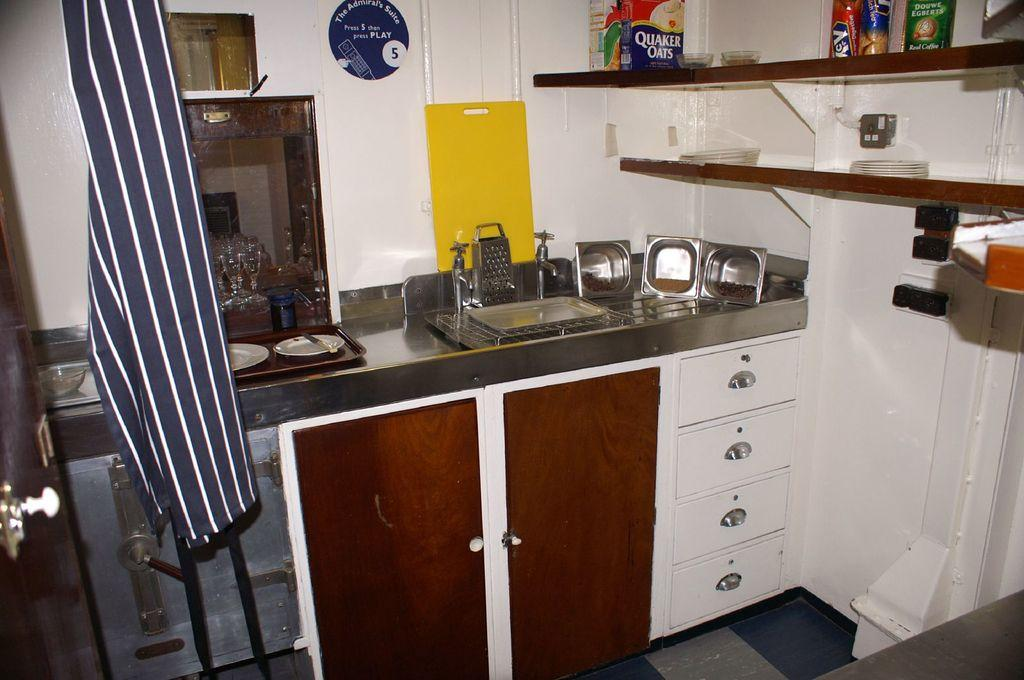<image>
Relay a brief, clear account of the picture shown. On the top shelf, you'll find a container of Quaker Oats. 